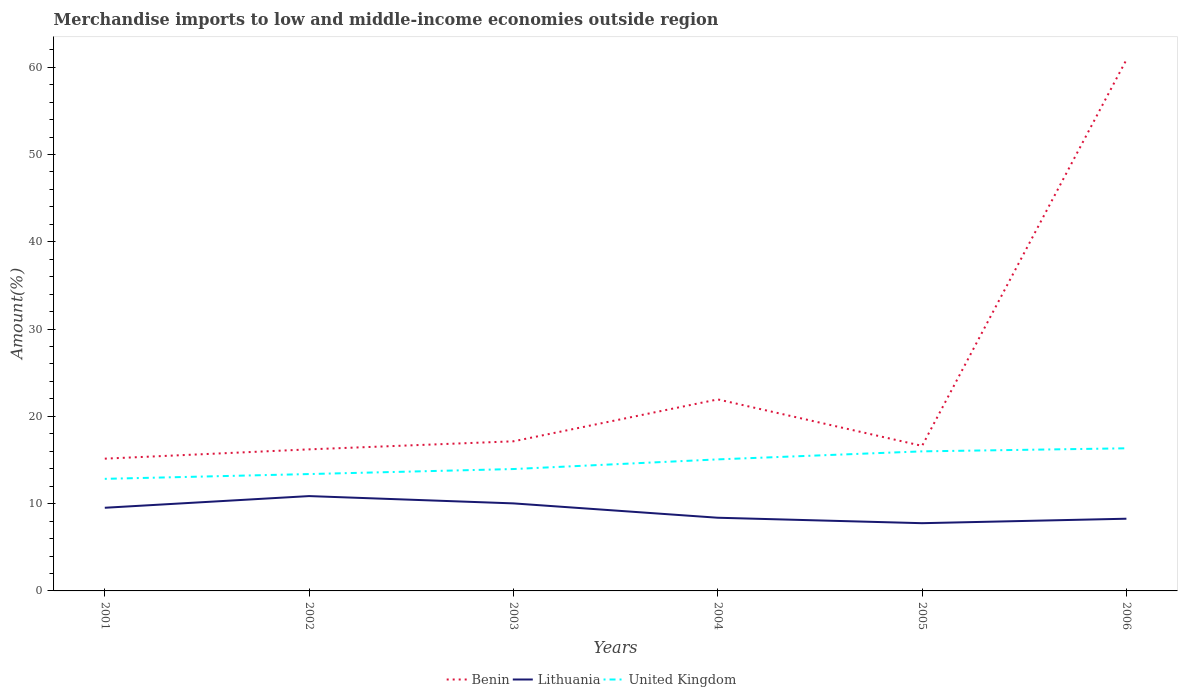Across all years, what is the maximum percentage of amount earned from merchandise imports in Benin?
Offer a terse response. 15.15. In which year was the percentage of amount earned from merchandise imports in United Kingdom maximum?
Give a very brief answer. 2001. What is the total percentage of amount earned from merchandise imports in Benin in the graph?
Your response must be concise. 0.52. What is the difference between the highest and the second highest percentage of amount earned from merchandise imports in Lithuania?
Provide a short and direct response. 3.11. What is the difference between two consecutive major ticks on the Y-axis?
Your answer should be very brief. 10. Are the values on the major ticks of Y-axis written in scientific E-notation?
Make the answer very short. No. How many legend labels are there?
Ensure brevity in your answer.  3. How are the legend labels stacked?
Provide a short and direct response. Horizontal. What is the title of the graph?
Offer a very short reply. Merchandise imports to low and middle-income economies outside region. What is the label or title of the Y-axis?
Your response must be concise. Amount(%). What is the Amount(%) in Benin in 2001?
Offer a terse response. 15.15. What is the Amount(%) in Lithuania in 2001?
Your answer should be compact. 9.53. What is the Amount(%) of United Kingdom in 2001?
Offer a terse response. 12.84. What is the Amount(%) of Benin in 2002?
Your answer should be very brief. 16.22. What is the Amount(%) of Lithuania in 2002?
Your response must be concise. 10.86. What is the Amount(%) in United Kingdom in 2002?
Provide a succinct answer. 13.39. What is the Amount(%) in Benin in 2003?
Give a very brief answer. 17.14. What is the Amount(%) of Lithuania in 2003?
Provide a succinct answer. 10.03. What is the Amount(%) in United Kingdom in 2003?
Make the answer very short. 13.96. What is the Amount(%) in Benin in 2004?
Offer a very short reply. 21.94. What is the Amount(%) of Lithuania in 2004?
Your response must be concise. 8.38. What is the Amount(%) in United Kingdom in 2004?
Make the answer very short. 15.07. What is the Amount(%) of Benin in 2005?
Make the answer very short. 16.62. What is the Amount(%) in Lithuania in 2005?
Your answer should be compact. 7.76. What is the Amount(%) in United Kingdom in 2005?
Provide a succinct answer. 15.99. What is the Amount(%) in Benin in 2006?
Your answer should be very brief. 60.85. What is the Amount(%) in Lithuania in 2006?
Keep it short and to the point. 8.27. What is the Amount(%) of United Kingdom in 2006?
Your answer should be compact. 16.34. Across all years, what is the maximum Amount(%) of Benin?
Your response must be concise. 60.85. Across all years, what is the maximum Amount(%) of Lithuania?
Keep it short and to the point. 10.86. Across all years, what is the maximum Amount(%) in United Kingdom?
Your response must be concise. 16.34. Across all years, what is the minimum Amount(%) in Benin?
Your answer should be very brief. 15.15. Across all years, what is the minimum Amount(%) of Lithuania?
Give a very brief answer. 7.76. Across all years, what is the minimum Amount(%) of United Kingdom?
Offer a terse response. 12.84. What is the total Amount(%) of Benin in the graph?
Make the answer very short. 147.92. What is the total Amount(%) in Lithuania in the graph?
Ensure brevity in your answer.  54.83. What is the total Amount(%) in United Kingdom in the graph?
Your answer should be compact. 87.59. What is the difference between the Amount(%) in Benin in 2001 and that in 2002?
Your response must be concise. -1.07. What is the difference between the Amount(%) of Lithuania in 2001 and that in 2002?
Your answer should be very brief. -1.34. What is the difference between the Amount(%) in United Kingdom in 2001 and that in 2002?
Ensure brevity in your answer.  -0.55. What is the difference between the Amount(%) in Benin in 2001 and that in 2003?
Offer a very short reply. -1.99. What is the difference between the Amount(%) in Lithuania in 2001 and that in 2003?
Offer a terse response. -0.5. What is the difference between the Amount(%) of United Kingdom in 2001 and that in 2003?
Ensure brevity in your answer.  -1.12. What is the difference between the Amount(%) in Benin in 2001 and that in 2004?
Ensure brevity in your answer.  -6.79. What is the difference between the Amount(%) in Lithuania in 2001 and that in 2004?
Your answer should be compact. 1.14. What is the difference between the Amount(%) in United Kingdom in 2001 and that in 2004?
Make the answer very short. -2.23. What is the difference between the Amount(%) of Benin in 2001 and that in 2005?
Give a very brief answer. -1.46. What is the difference between the Amount(%) of Lithuania in 2001 and that in 2005?
Offer a terse response. 1.77. What is the difference between the Amount(%) of United Kingdom in 2001 and that in 2005?
Provide a short and direct response. -3.15. What is the difference between the Amount(%) of Benin in 2001 and that in 2006?
Your answer should be compact. -45.7. What is the difference between the Amount(%) of Lithuania in 2001 and that in 2006?
Your answer should be compact. 1.25. What is the difference between the Amount(%) of United Kingdom in 2001 and that in 2006?
Give a very brief answer. -3.5. What is the difference between the Amount(%) of Benin in 2002 and that in 2003?
Ensure brevity in your answer.  -0.92. What is the difference between the Amount(%) in Lithuania in 2002 and that in 2003?
Offer a terse response. 0.84. What is the difference between the Amount(%) of United Kingdom in 2002 and that in 2003?
Offer a terse response. -0.57. What is the difference between the Amount(%) in Benin in 2002 and that in 2004?
Make the answer very short. -5.72. What is the difference between the Amount(%) of Lithuania in 2002 and that in 2004?
Offer a terse response. 2.48. What is the difference between the Amount(%) of United Kingdom in 2002 and that in 2004?
Ensure brevity in your answer.  -1.68. What is the difference between the Amount(%) in Benin in 2002 and that in 2005?
Your answer should be compact. -0.4. What is the difference between the Amount(%) of Lithuania in 2002 and that in 2005?
Make the answer very short. 3.11. What is the difference between the Amount(%) in United Kingdom in 2002 and that in 2005?
Offer a terse response. -2.6. What is the difference between the Amount(%) of Benin in 2002 and that in 2006?
Provide a succinct answer. -44.63. What is the difference between the Amount(%) in Lithuania in 2002 and that in 2006?
Your answer should be very brief. 2.59. What is the difference between the Amount(%) in United Kingdom in 2002 and that in 2006?
Offer a terse response. -2.95. What is the difference between the Amount(%) of Benin in 2003 and that in 2004?
Give a very brief answer. -4.8. What is the difference between the Amount(%) of Lithuania in 2003 and that in 2004?
Provide a succinct answer. 1.64. What is the difference between the Amount(%) of United Kingdom in 2003 and that in 2004?
Your answer should be very brief. -1.1. What is the difference between the Amount(%) of Benin in 2003 and that in 2005?
Provide a succinct answer. 0.52. What is the difference between the Amount(%) in Lithuania in 2003 and that in 2005?
Ensure brevity in your answer.  2.27. What is the difference between the Amount(%) in United Kingdom in 2003 and that in 2005?
Give a very brief answer. -2.02. What is the difference between the Amount(%) in Benin in 2003 and that in 2006?
Offer a terse response. -43.71. What is the difference between the Amount(%) of Lithuania in 2003 and that in 2006?
Ensure brevity in your answer.  1.76. What is the difference between the Amount(%) of United Kingdom in 2003 and that in 2006?
Ensure brevity in your answer.  -2.38. What is the difference between the Amount(%) of Benin in 2004 and that in 2005?
Keep it short and to the point. 5.33. What is the difference between the Amount(%) in Lithuania in 2004 and that in 2005?
Provide a short and direct response. 0.62. What is the difference between the Amount(%) in United Kingdom in 2004 and that in 2005?
Provide a succinct answer. -0.92. What is the difference between the Amount(%) of Benin in 2004 and that in 2006?
Your response must be concise. -38.91. What is the difference between the Amount(%) in Lithuania in 2004 and that in 2006?
Provide a short and direct response. 0.11. What is the difference between the Amount(%) of United Kingdom in 2004 and that in 2006?
Your answer should be compact. -1.27. What is the difference between the Amount(%) in Benin in 2005 and that in 2006?
Your answer should be very brief. -44.24. What is the difference between the Amount(%) of Lithuania in 2005 and that in 2006?
Ensure brevity in your answer.  -0.51. What is the difference between the Amount(%) of United Kingdom in 2005 and that in 2006?
Keep it short and to the point. -0.35. What is the difference between the Amount(%) of Benin in 2001 and the Amount(%) of Lithuania in 2002?
Offer a terse response. 4.29. What is the difference between the Amount(%) of Benin in 2001 and the Amount(%) of United Kingdom in 2002?
Give a very brief answer. 1.76. What is the difference between the Amount(%) in Lithuania in 2001 and the Amount(%) in United Kingdom in 2002?
Your answer should be very brief. -3.86. What is the difference between the Amount(%) of Benin in 2001 and the Amount(%) of Lithuania in 2003?
Give a very brief answer. 5.12. What is the difference between the Amount(%) of Benin in 2001 and the Amount(%) of United Kingdom in 2003?
Provide a succinct answer. 1.19. What is the difference between the Amount(%) in Lithuania in 2001 and the Amount(%) in United Kingdom in 2003?
Provide a succinct answer. -4.44. What is the difference between the Amount(%) of Benin in 2001 and the Amount(%) of Lithuania in 2004?
Ensure brevity in your answer.  6.77. What is the difference between the Amount(%) in Benin in 2001 and the Amount(%) in United Kingdom in 2004?
Make the answer very short. 0.08. What is the difference between the Amount(%) of Lithuania in 2001 and the Amount(%) of United Kingdom in 2004?
Ensure brevity in your answer.  -5.54. What is the difference between the Amount(%) of Benin in 2001 and the Amount(%) of Lithuania in 2005?
Your response must be concise. 7.39. What is the difference between the Amount(%) of Benin in 2001 and the Amount(%) of United Kingdom in 2005?
Give a very brief answer. -0.84. What is the difference between the Amount(%) in Lithuania in 2001 and the Amount(%) in United Kingdom in 2005?
Your answer should be compact. -6.46. What is the difference between the Amount(%) in Benin in 2001 and the Amount(%) in Lithuania in 2006?
Your answer should be very brief. 6.88. What is the difference between the Amount(%) of Benin in 2001 and the Amount(%) of United Kingdom in 2006?
Your answer should be compact. -1.19. What is the difference between the Amount(%) of Lithuania in 2001 and the Amount(%) of United Kingdom in 2006?
Ensure brevity in your answer.  -6.81. What is the difference between the Amount(%) in Benin in 2002 and the Amount(%) in Lithuania in 2003?
Ensure brevity in your answer.  6.19. What is the difference between the Amount(%) in Benin in 2002 and the Amount(%) in United Kingdom in 2003?
Offer a terse response. 2.25. What is the difference between the Amount(%) of Lithuania in 2002 and the Amount(%) of United Kingdom in 2003?
Ensure brevity in your answer.  -3.1. What is the difference between the Amount(%) of Benin in 2002 and the Amount(%) of Lithuania in 2004?
Keep it short and to the point. 7.83. What is the difference between the Amount(%) in Benin in 2002 and the Amount(%) in United Kingdom in 2004?
Your answer should be compact. 1.15. What is the difference between the Amount(%) of Lithuania in 2002 and the Amount(%) of United Kingdom in 2004?
Make the answer very short. -4.2. What is the difference between the Amount(%) of Benin in 2002 and the Amount(%) of Lithuania in 2005?
Offer a very short reply. 8.46. What is the difference between the Amount(%) of Benin in 2002 and the Amount(%) of United Kingdom in 2005?
Ensure brevity in your answer.  0.23. What is the difference between the Amount(%) in Lithuania in 2002 and the Amount(%) in United Kingdom in 2005?
Your answer should be compact. -5.12. What is the difference between the Amount(%) in Benin in 2002 and the Amount(%) in Lithuania in 2006?
Give a very brief answer. 7.95. What is the difference between the Amount(%) of Benin in 2002 and the Amount(%) of United Kingdom in 2006?
Your response must be concise. -0.12. What is the difference between the Amount(%) in Lithuania in 2002 and the Amount(%) in United Kingdom in 2006?
Ensure brevity in your answer.  -5.48. What is the difference between the Amount(%) in Benin in 2003 and the Amount(%) in Lithuania in 2004?
Make the answer very short. 8.76. What is the difference between the Amount(%) of Benin in 2003 and the Amount(%) of United Kingdom in 2004?
Ensure brevity in your answer.  2.07. What is the difference between the Amount(%) of Lithuania in 2003 and the Amount(%) of United Kingdom in 2004?
Keep it short and to the point. -5.04. What is the difference between the Amount(%) of Benin in 2003 and the Amount(%) of Lithuania in 2005?
Give a very brief answer. 9.38. What is the difference between the Amount(%) in Benin in 2003 and the Amount(%) in United Kingdom in 2005?
Give a very brief answer. 1.15. What is the difference between the Amount(%) of Lithuania in 2003 and the Amount(%) of United Kingdom in 2005?
Provide a succinct answer. -5.96. What is the difference between the Amount(%) of Benin in 2003 and the Amount(%) of Lithuania in 2006?
Provide a short and direct response. 8.87. What is the difference between the Amount(%) of Benin in 2003 and the Amount(%) of United Kingdom in 2006?
Your answer should be compact. 0.8. What is the difference between the Amount(%) in Lithuania in 2003 and the Amount(%) in United Kingdom in 2006?
Ensure brevity in your answer.  -6.31. What is the difference between the Amount(%) in Benin in 2004 and the Amount(%) in Lithuania in 2005?
Offer a very short reply. 14.18. What is the difference between the Amount(%) of Benin in 2004 and the Amount(%) of United Kingdom in 2005?
Make the answer very short. 5.95. What is the difference between the Amount(%) of Lithuania in 2004 and the Amount(%) of United Kingdom in 2005?
Make the answer very short. -7.6. What is the difference between the Amount(%) in Benin in 2004 and the Amount(%) in Lithuania in 2006?
Offer a terse response. 13.67. What is the difference between the Amount(%) of Benin in 2004 and the Amount(%) of United Kingdom in 2006?
Your response must be concise. 5.6. What is the difference between the Amount(%) in Lithuania in 2004 and the Amount(%) in United Kingdom in 2006?
Provide a short and direct response. -7.96. What is the difference between the Amount(%) in Benin in 2005 and the Amount(%) in Lithuania in 2006?
Offer a terse response. 8.34. What is the difference between the Amount(%) of Benin in 2005 and the Amount(%) of United Kingdom in 2006?
Your answer should be very brief. 0.28. What is the difference between the Amount(%) in Lithuania in 2005 and the Amount(%) in United Kingdom in 2006?
Give a very brief answer. -8.58. What is the average Amount(%) in Benin per year?
Offer a very short reply. 24.65. What is the average Amount(%) of Lithuania per year?
Give a very brief answer. 9.14. What is the average Amount(%) in United Kingdom per year?
Your response must be concise. 14.6. In the year 2001, what is the difference between the Amount(%) of Benin and Amount(%) of Lithuania?
Offer a very short reply. 5.63. In the year 2001, what is the difference between the Amount(%) of Benin and Amount(%) of United Kingdom?
Give a very brief answer. 2.31. In the year 2001, what is the difference between the Amount(%) of Lithuania and Amount(%) of United Kingdom?
Make the answer very short. -3.31. In the year 2002, what is the difference between the Amount(%) of Benin and Amount(%) of Lithuania?
Give a very brief answer. 5.35. In the year 2002, what is the difference between the Amount(%) in Benin and Amount(%) in United Kingdom?
Your response must be concise. 2.83. In the year 2002, what is the difference between the Amount(%) of Lithuania and Amount(%) of United Kingdom?
Ensure brevity in your answer.  -2.52. In the year 2003, what is the difference between the Amount(%) in Benin and Amount(%) in Lithuania?
Your answer should be very brief. 7.11. In the year 2003, what is the difference between the Amount(%) in Benin and Amount(%) in United Kingdom?
Ensure brevity in your answer.  3.18. In the year 2003, what is the difference between the Amount(%) of Lithuania and Amount(%) of United Kingdom?
Keep it short and to the point. -3.94. In the year 2004, what is the difference between the Amount(%) of Benin and Amount(%) of Lithuania?
Your answer should be very brief. 13.56. In the year 2004, what is the difference between the Amount(%) of Benin and Amount(%) of United Kingdom?
Your response must be concise. 6.87. In the year 2004, what is the difference between the Amount(%) of Lithuania and Amount(%) of United Kingdom?
Ensure brevity in your answer.  -6.68. In the year 2005, what is the difference between the Amount(%) of Benin and Amount(%) of Lithuania?
Provide a short and direct response. 8.86. In the year 2005, what is the difference between the Amount(%) of Benin and Amount(%) of United Kingdom?
Offer a very short reply. 0.63. In the year 2005, what is the difference between the Amount(%) in Lithuania and Amount(%) in United Kingdom?
Provide a short and direct response. -8.23. In the year 2006, what is the difference between the Amount(%) of Benin and Amount(%) of Lithuania?
Your answer should be very brief. 52.58. In the year 2006, what is the difference between the Amount(%) of Benin and Amount(%) of United Kingdom?
Offer a terse response. 44.51. In the year 2006, what is the difference between the Amount(%) of Lithuania and Amount(%) of United Kingdom?
Provide a short and direct response. -8.07. What is the ratio of the Amount(%) of Benin in 2001 to that in 2002?
Your response must be concise. 0.93. What is the ratio of the Amount(%) in Lithuania in 2001 to that in 2002?
Offer a terse response. 0.88. What is the ratio of the Amount(%) of United Kingdom in 2001 to that in 2002?
Your answer should be very brief. 0.96. What is the ratio of the Amount(%) of Benin in 2001 to that in 2003?
Ensure brevity in your answer.  0.88. What is the ratio of the Amount(%) in Lithuania in 2001 to that in 2003?
Ensure brevity in your answer.  0.95. What is the ratio of the Amount(%) of United Kingdom in 2001 to that in 2003?
Your answer should be very brief. 0.92. What is the ratio of the Amount(%) of Benin in 2001 to that in 2004?
Give a very brief answer. 0.69. What is the ratio of the Amount(%) in Lithuania in 2001 to that in 2004?
Offer a terse response. 1.14. What is the ratio of the Amount(%) in United Kingdom in 2001 to that in 2004?
Give a very brief answer. 0.85. What is the ratio of the Amount(%) of Benin in 2001 to that in 2005?
Your answer should be compact. 0.91. What is the ratio of the Amount(%) in Lithuania in 2001 to that in 2005?
Provide a succinct answer. 1.23. What is the ratio of the Amount(%) in United Kingdom in 2001 to that in 2005?
Offer a very short reply. 0.8. What is the ratio of the Amount(%) of Benin in 2001 to that in 2006?
Make the answer very short. 0.25. What is the ratio of the Amount(%) in Lithuania in 2001 to that in 2006?
Provide a short and direct response. 1.15. What is the ratio of the Amount(%) in United Kingdom in 2001 to that in 2006?
Provide a succinct answer. 0.79. What is the ratio of the Amount(%) of Benin in 2002 to that in 2003?
Make the answer very short. 0.95. What is the ratio of the Amount(%) in Lithuania in 2002 to that in 2003?
Your response must be concise. 1.08. What is the ratio of the Amount(%) in United Kingdom in 2002 to that in 2003?
Your response must be concise. 0.96. What is the ratio of the Amount(%) of Benin in 2002 to that in 2004?
Your answer should be very brief. 0.74. What is the ratio of the Amount(%) in Lithuania in 2002 to that in 2004?
Offer a very short reply. 1.3. What is the ratio of the Amount(%) in United Kingdom in 2002 to that in 2004?
Your answer should be compact. 0.89. What is the ratio of the Amount(%) in Benin in 2002 to that in 2005?
Ensure brevity in your answer.  0.98. What is the ratio of the Amount(%) in Lithuania in 2002 to that in 2005?
Keep it short and to the point. 1.4. What is the ratio of the Amount(%) of United Kingdom in 2002 to that in 2005?
Offer a terse response. 0.84. What is the ratio of the Amount(%) of Benin in 2002 to that in 2006?
Give a very brief answer. 0.27. What is the ratio of the Amount(%) of Lithuania in 2002 to that in 2006?
Provide a succinct answer. 1.31. What is the ratio of the Amount(%) in United Kingdom in 2002 to that in 2006?
Your answer should be compact. 0.82. What is the ratio of the Amount(%) in Benin in 2003 to that in 2004?
Provide a succinct answer. 0.78. What is the ratio of the Amount(%) in Lithuania in 2003 to that in 2004?
Give a very brief answer. 1.2. What is the ratio of the Amount(%) in United Kingdom in 2003 to that in 2004?
Keep it short and to the point. 0.93. What is the ratio of the Amount(%) of Benin in 2003 to that in 2005?
Provide a short and direct response. 1.03. What is the ratio of the Amount(%) in Lithuania in 2003 to that in 2005?
Provide a succinct answer. 1.29. What is the ratio of the Amount(%) in United Kingdom in 2003 to that in 2005?
Offer a terse response. 0.87. What is the ratio of the Amount(%) of Benin in 2003 to that in 2006?
Your answer should be very brief. 0.28. What is the ratio of the Amount(%) of Lithuania in 2003 to that in 2006?
Your answer should be compact. 1.21. What is the ratio of the Amount(%) of United Kingdom in 2003 to that in 2006?
Offer a terse response. 0.85. What is the ratio of the Amount(%) in Benin in 2004 to that in 2005?
Your answer should be compact. 1.32. What is the ratio of the Amount(%) in Lithuania in 2004 to that in 2005?
Offer a very short reply. 1.08. What is the ratio of the Amount(%) of United Kingdom in 2004 to that in 2005?
Provide a short and direct response. 0.94. What is the ratio of the Amount(%) of Benin in 2004 to that in 2006?
Give a very brief answer. 0.36. What is the ratio of the Amount(%) of Lithuania in 2004 to that in 2006?
Provide a succinct answer. 1.01. What is the ratio of the Amount(%) of United Kingdom in 2004 to that in 2006?
Your answer should be very brief. 0.92. What is the ratio of the Amount(%) of Benin in 2005 to that in 2006?
Offer a terse response. 0.27. What is the ratio of the Amount(%) in Lithuania in 2005 to that in 2006?
Ensure brevity in your answer.  0.94. What is the ratio of the Amount(%) of United Kingdom in 2005 to that in 2006?
Offer a terse response. 0.98. What is the difference between the highest and the second highest Amount(%) of Benin?
Give a very brief answer. 38.91. What is the difference between the highest and the second highest Amount(%) in Lithuania?
Keep it short and to the point. 0.84. What is the difference between the highest and the second highest Amount(%) in United Kingdom?
Provide a short and direct response. 0.35. What is the difference between the highest and the lowest Amount(%) of Benin?
Your answer should be compact. 45.7. What is the difference between the highest and the lowest Amount(%) in Lithuania?
Provide a short and direct response. 3.11. What is the difference between the highest and the lowest Amount(%) in United Kingdom?
Provide a short and direct response. 3.5. 